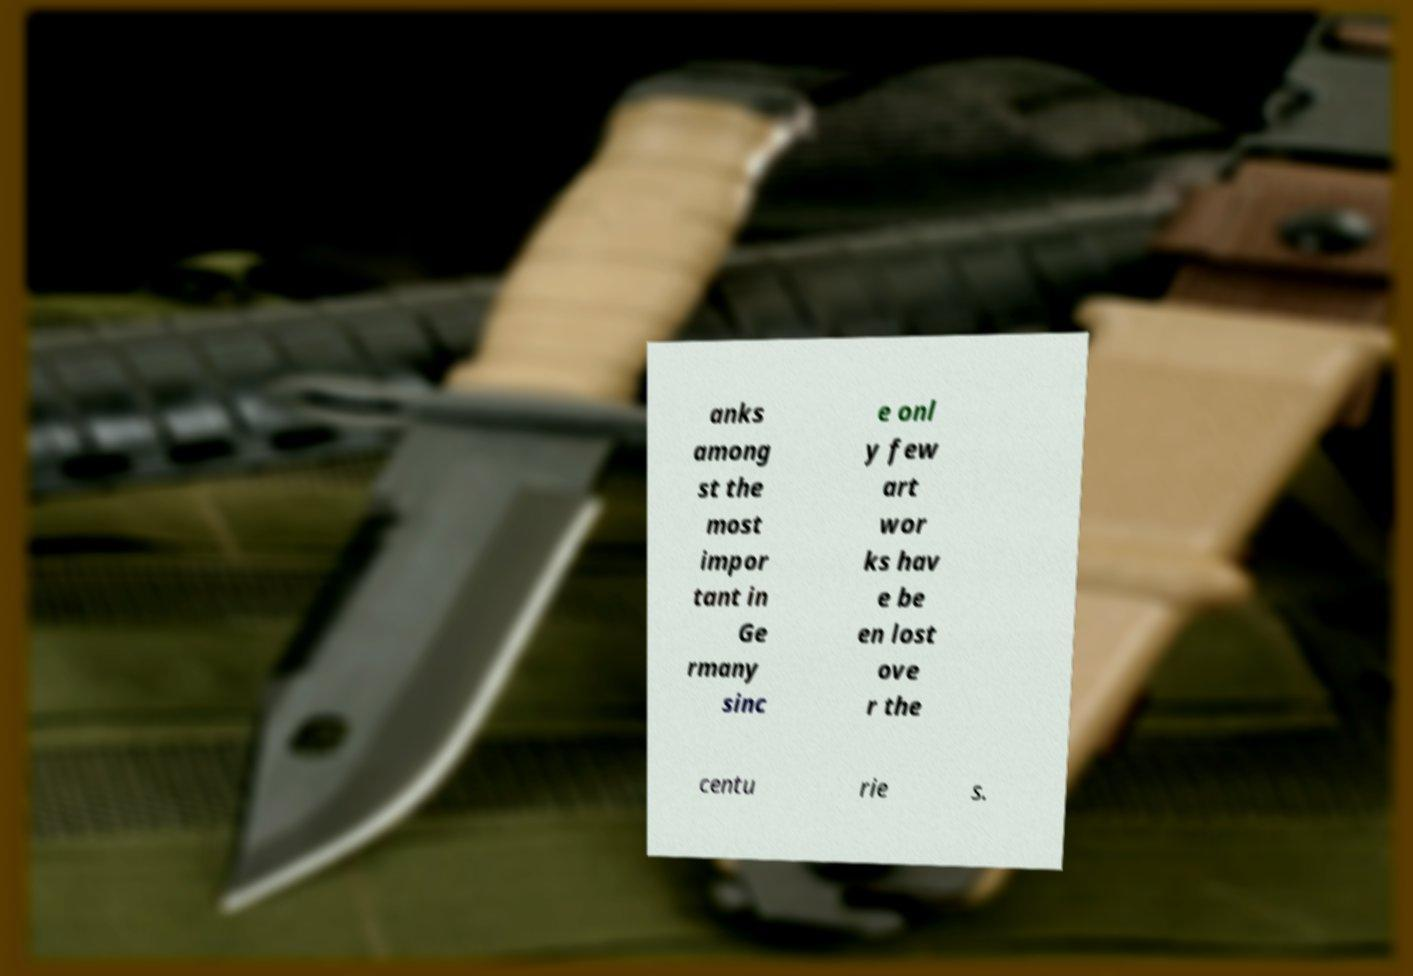Please identify and transcribe the text found in this image. anks among st the most impor tant in Ge rmany sinc e onl y few art wor ks hav e be en lost ove r the centu rie s. 